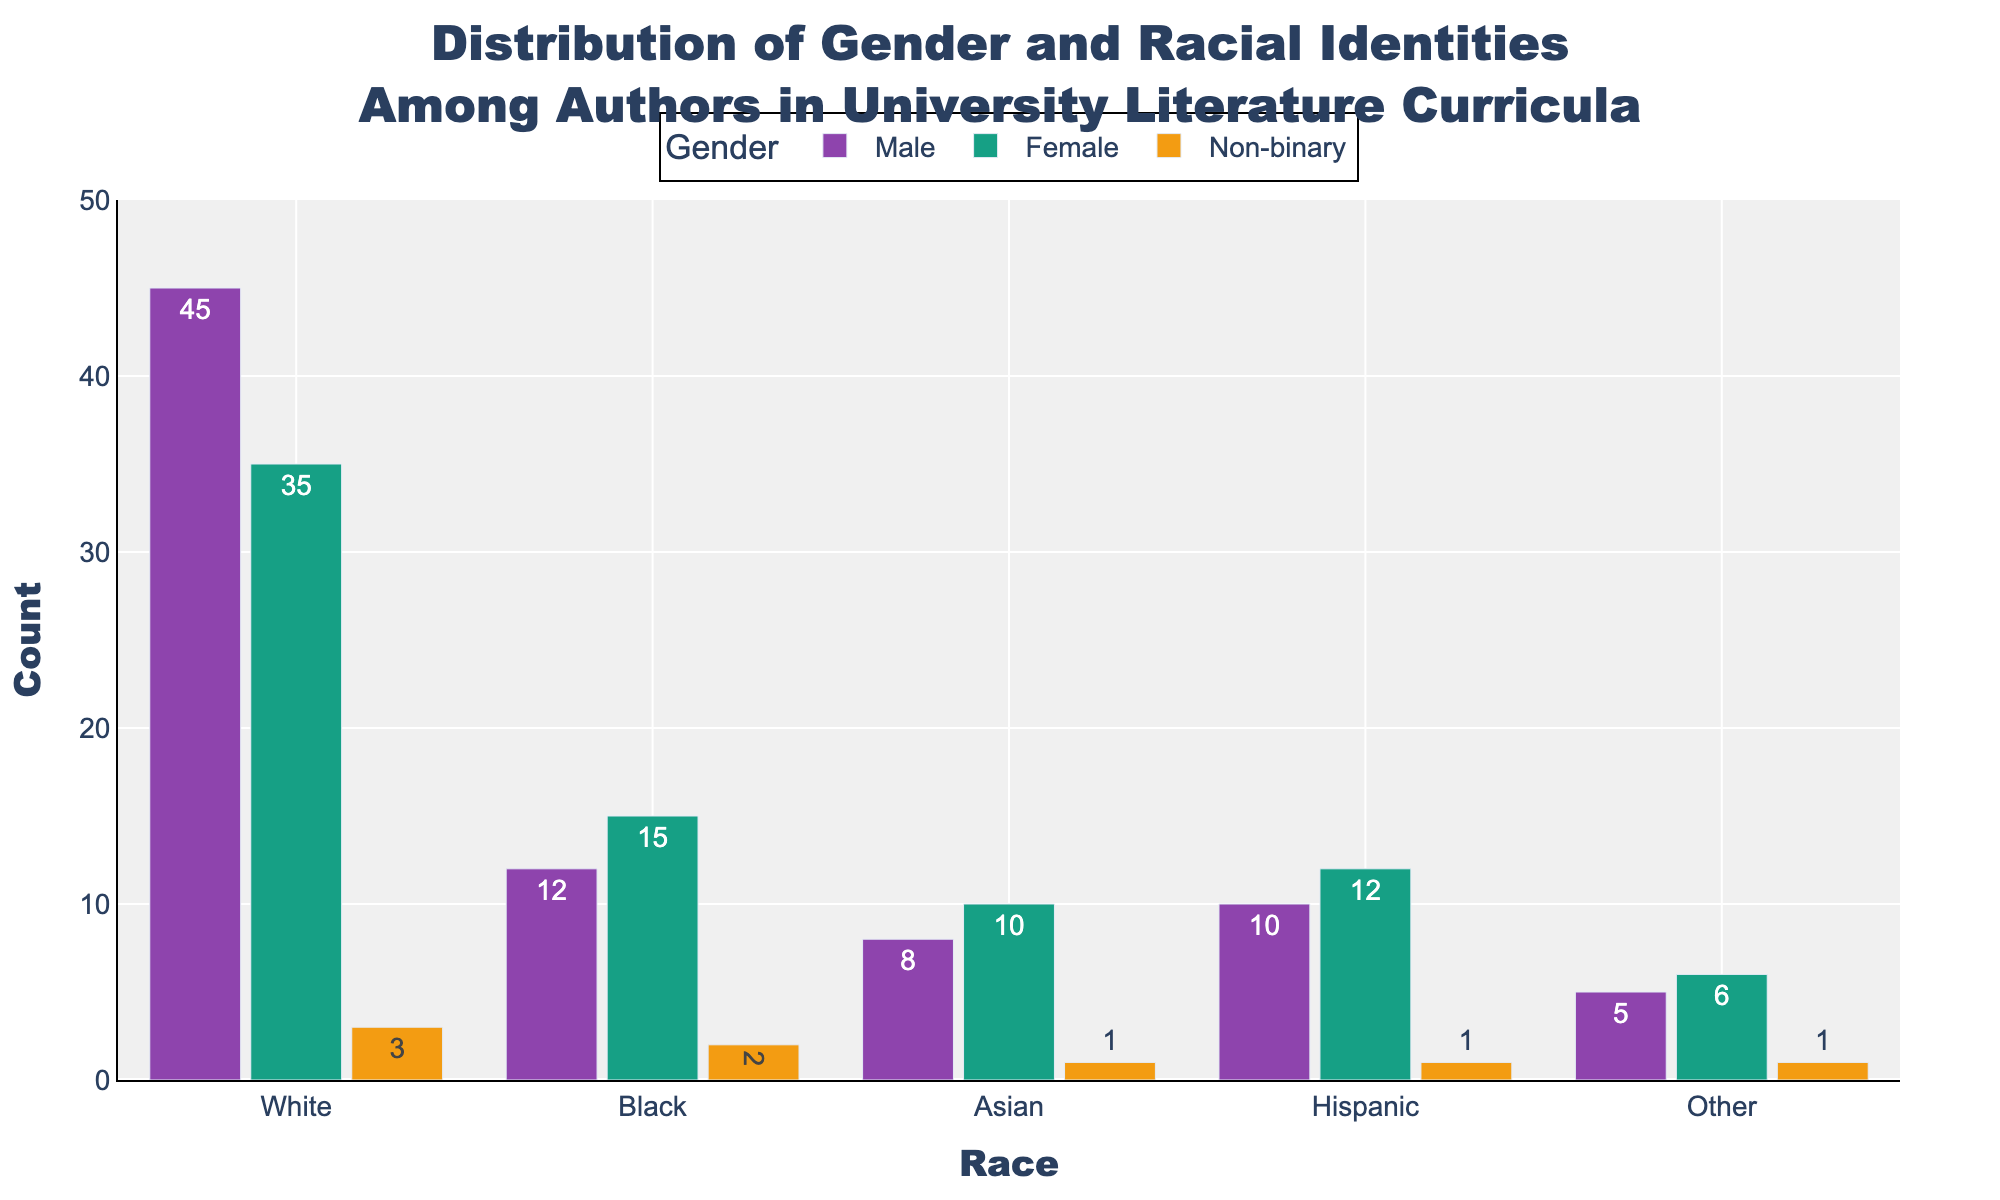Which racial group has the highest count of male authors? To determine this, we need to look at the bars representing male authors for each racial group. The bar for White male authors is the tallest, indicating this group has the highest count.
Answer: White Which gender has the highest representation among Black authors? We compare the heights of the bars representing Black authors for each gender. The bar for female Black authors is the tallest.
Answer: Female What is the total count of authors in the 'Hispanic' racial category? Sum the counts of Hispanic authors for all genders: (Male) 10 + (Female) 12 + (Non-binary) 1. That gives us a total of 23.
Answer: 23 What is the difference between the number of male and female White authors? Subtract the count of female White authors from the count of male White authors. That’s 45 - 35 = 10.
Answer: 10 Which gender has the least representation among Asian authors? By comparing the heights of the bars for Asian authors, the shortest bar is for non-binary authors.
Answer: Non-binary For the 'Other' racial category, what is the combined total number of male and female authors? Add the counts of male and female authors in the 'Other' category: 5 (Male) + 6 (Female) = 11.
Answer: 11 What is the range of total female authors across all racial groups? Sum the counts of female authors: 35 (White) + 15 (Black) + 10 (Asian) + 12 (Hispanic) + 6 (Other) = 78. The range is from 0 to 78.
Answer: 78 Which racial category has the smallest gender disparity? To find the smallest disparity, we compare the differences in counts between each gender within each racial group. For 'Other' authors, the differences are (5 Male - 6 Female = 1), (5 Male - 1 Non-binary = 4), and (6 Female - 1 Non-binary = 5). The smallest disparity is 1.
Answer: Other What proportion of the total authors are non-binary? Sum the counts of all non-binary authors and divide by the total count of all authors. That’s (3 White + 2 Black + 1 Asian + 1 Hispanic + 1 Other) = 8 non-binary authors. The total count of all authors is 143. So, the proportion is 8 / 143 ≈ 0.056, or approximately 5.6%.
Answer: 5.6% Which racial category has the highest overall number of authors? Sum the author counts for each racial category across all genders. The highest total will be for the category with the highest sum. The sums are: White (45+35+3 = 83), Black (12+15+2 = 29), Asian (8+10+1 = 19), Hispanic (10+12+1 = 23), Other (5+6+1 = 12). The White category has the highest total.
Answer: White 